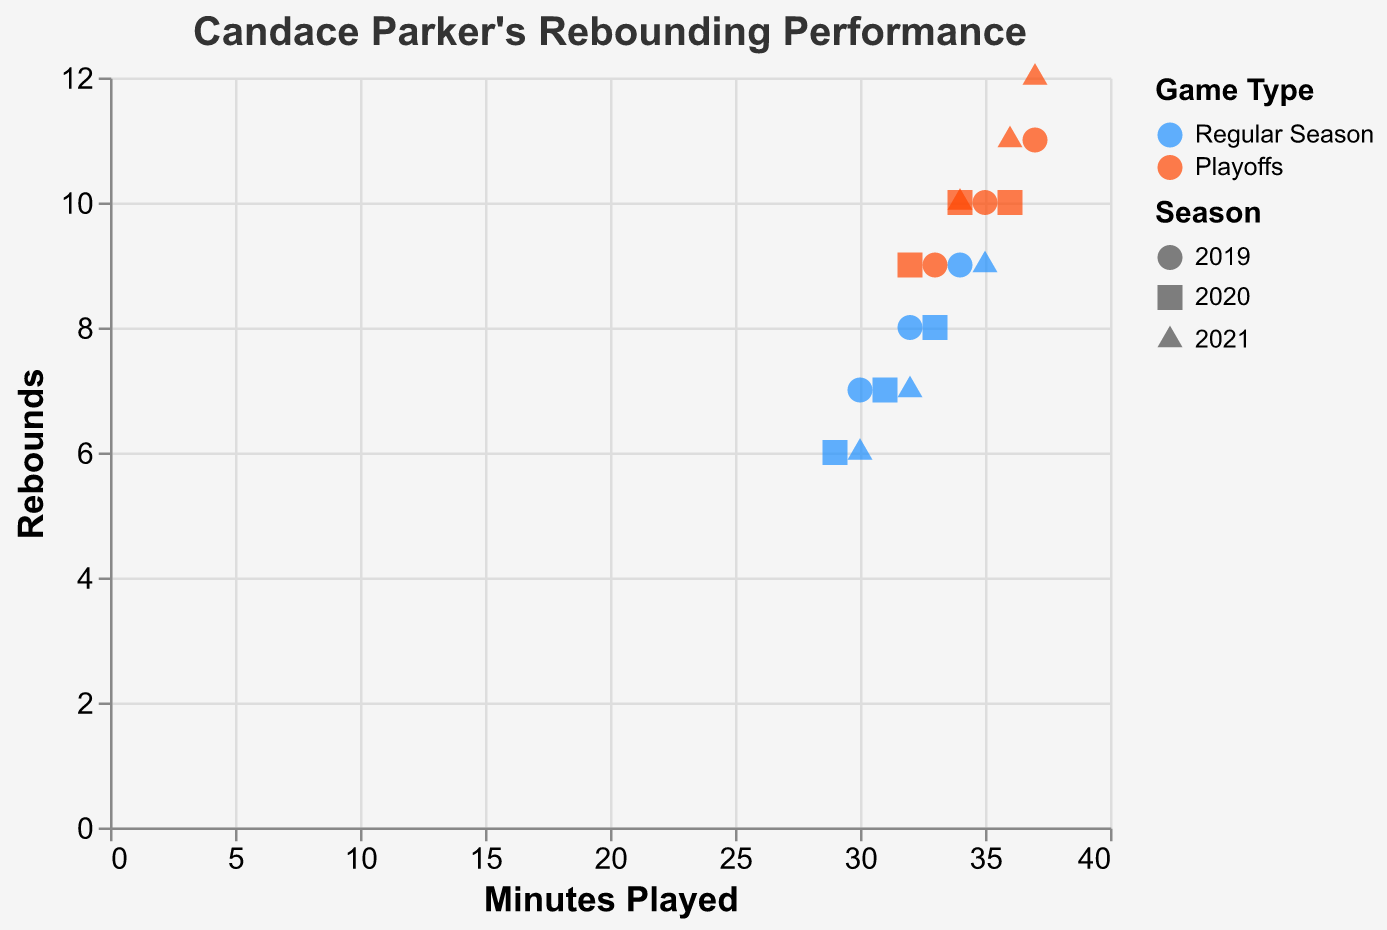What is the title of the grouped scatter plot? The title is at the top of the plot and describes the subject. It reads "Candace Parker's Rebounding Performance."
Answer: Candace Parker's Rebounding Performance What are the two different game types represented by color in the plot? The legend indicates that colors represent different game types. The colors are blue for Regular Season and red for Playoffs.
Answer: Regular Season, Playoffs How many data points represent Candace Parker's performance in the 2019 Regular Season? Count all points shown with the "circle" shape and colored in blue to identify the 2019 Regular Season. There are 3 such points.
Answer: 3 Which season is represented by the square shape? The legend indicates different shapes for each season. The square represents the 2020 season.
Answer: 2020 What is the range of minutes played in the Playoffs? Observe the x-axis values for points colored in red. The range is between 32 and 37 minutes.
Answer: 32 to 37 minutes Compare the average number of rebounds in regular season games vs. playoff games in 2020. Identify points in 2020 (squares). Regular Season rebounds: 7, 6, 8. Playoff rebounds: 10, 9, 10. Calculate the averages. Regular Season: (7+6+8)/3 = 7. Playoffs: (10+9+10)/3 = 9.67.
Answer: 7 for Regular Season, 9.67 for Playoffs Which season had the highest recorded rebounds in Playoff games? Examine red points for each season. 2019 max: 11, 2020 max: 10, 2021 max: 12. The highest is 12 in 2021.
Answer: 2021 Are there any data points where Candace Parker played fewer than 30 minutes? Check the x-axis values to see any points below 30 minutes. One point at 29 minutes in the 2020 Regular Season.
Answer: Yes In which season did Candace Parker have the highest average rebounds in the Regular Season? Calculate the average rebounds for Regular Season data in each year:
2019: (8+7+9)/3 = 8,
2020: (7+6+8)/3 = 7,
2021: (6+7+9)/3 = 7.33. Higher average is 8 in 2019.
Answer: 2019 